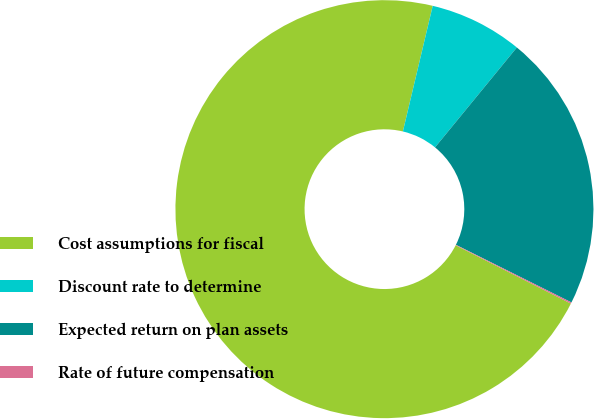<chart> <loc_0><loc_0><loc_500><loc_500><pie_chart><fcel>Cost assumptions for fiscal<fcel>Discount rate to determine<fcel>Expected return on plan assets<fcel>Rate of future compensation<nl><fcel>71.25%<fcel>7.21%<fcel>21.44%<fcel>0.1%<nl></chart> 